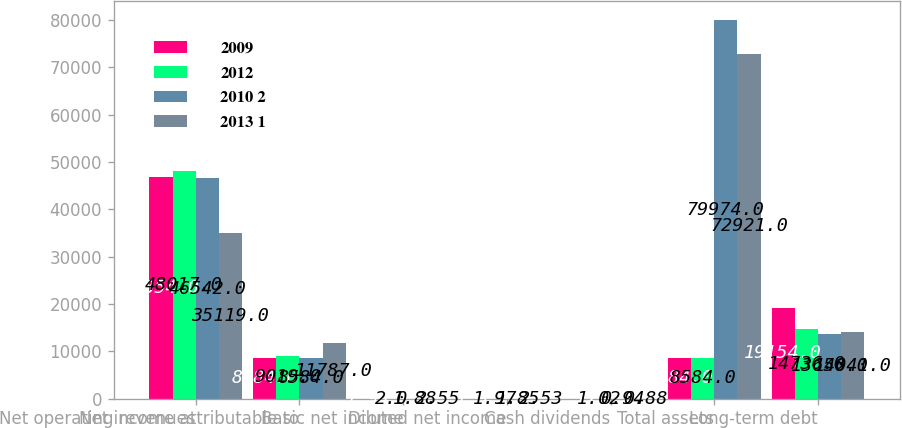Convert chart to OTSL. <chart><loc_0><loc_0><loc_500><loc_500><stacked_bar_chart><ecel><fcel>Net operating revenues<fcel>Net income attributable to<fcel>Basic net income<fcel>Diluted net income<fcel>Cash dividends<fcel>Total assets<fcel>Long-term debt<nl><fcel>2009<fcel>46854<fcel>8584<fcel>1.94<fcel>1.9<fcel>1.12<fcel>8584<fcel>19154<nl><fcel>2012<fcel>48017<fcel>9019<fcel>2<fcel>1.97<fcel>1.02<fcel>8584<fcel>14736<nl><fcel>2010 2<fcel>46542<fcel>8584<fcel>1.88<fcel>1.85<fcel>0.94<fcel>79974<fcel>13656<nl><fcel>2013 1<fcel>35119<fcel>11787<fcel>2.55<fcel>2.53<fcel>0.88<fcel>72921<fcel>14041<nl></chart> 